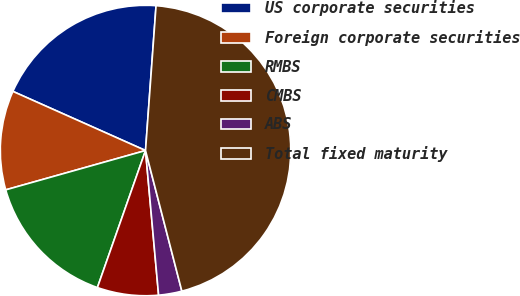<chart> <loc_0><loc_0><loc_500><loc_500><pie_chart><fcel>US corporate securities<fcel>Foreign corporate securities<fcel>RMBS<fcel>CMBS<fcel>ABS<fcel>Total fixed maturity<nl><fcel>19.48%<fcel>11.04%<fcel>15.26%<fcel>6.81%<fcel>2.59%<fcel>44.82%<nl></chart> 